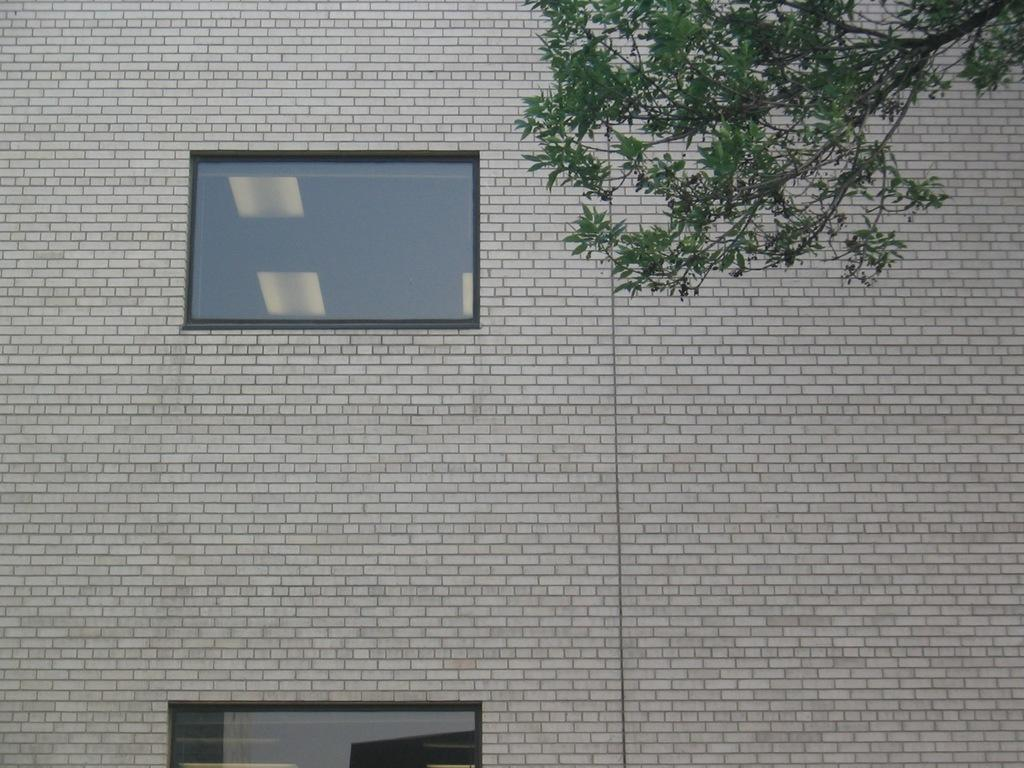What type of structure is visible in the picture? There is a brick wall in the picture. What can be seen in the center of the picture? There are glass windows in the center of the picture. What type of vegetation is on the right side of the picture? There is a stem of a tree on the right side of the picture. How many snails are crawling on the brick wall in the picture? There are no snails visible on the brick wall in the picture. What is the afterthought of the person who designed the tree stem in the picture? There is no information provided about the designer's intentions or afterthoughts, so we cannot answer this question. 